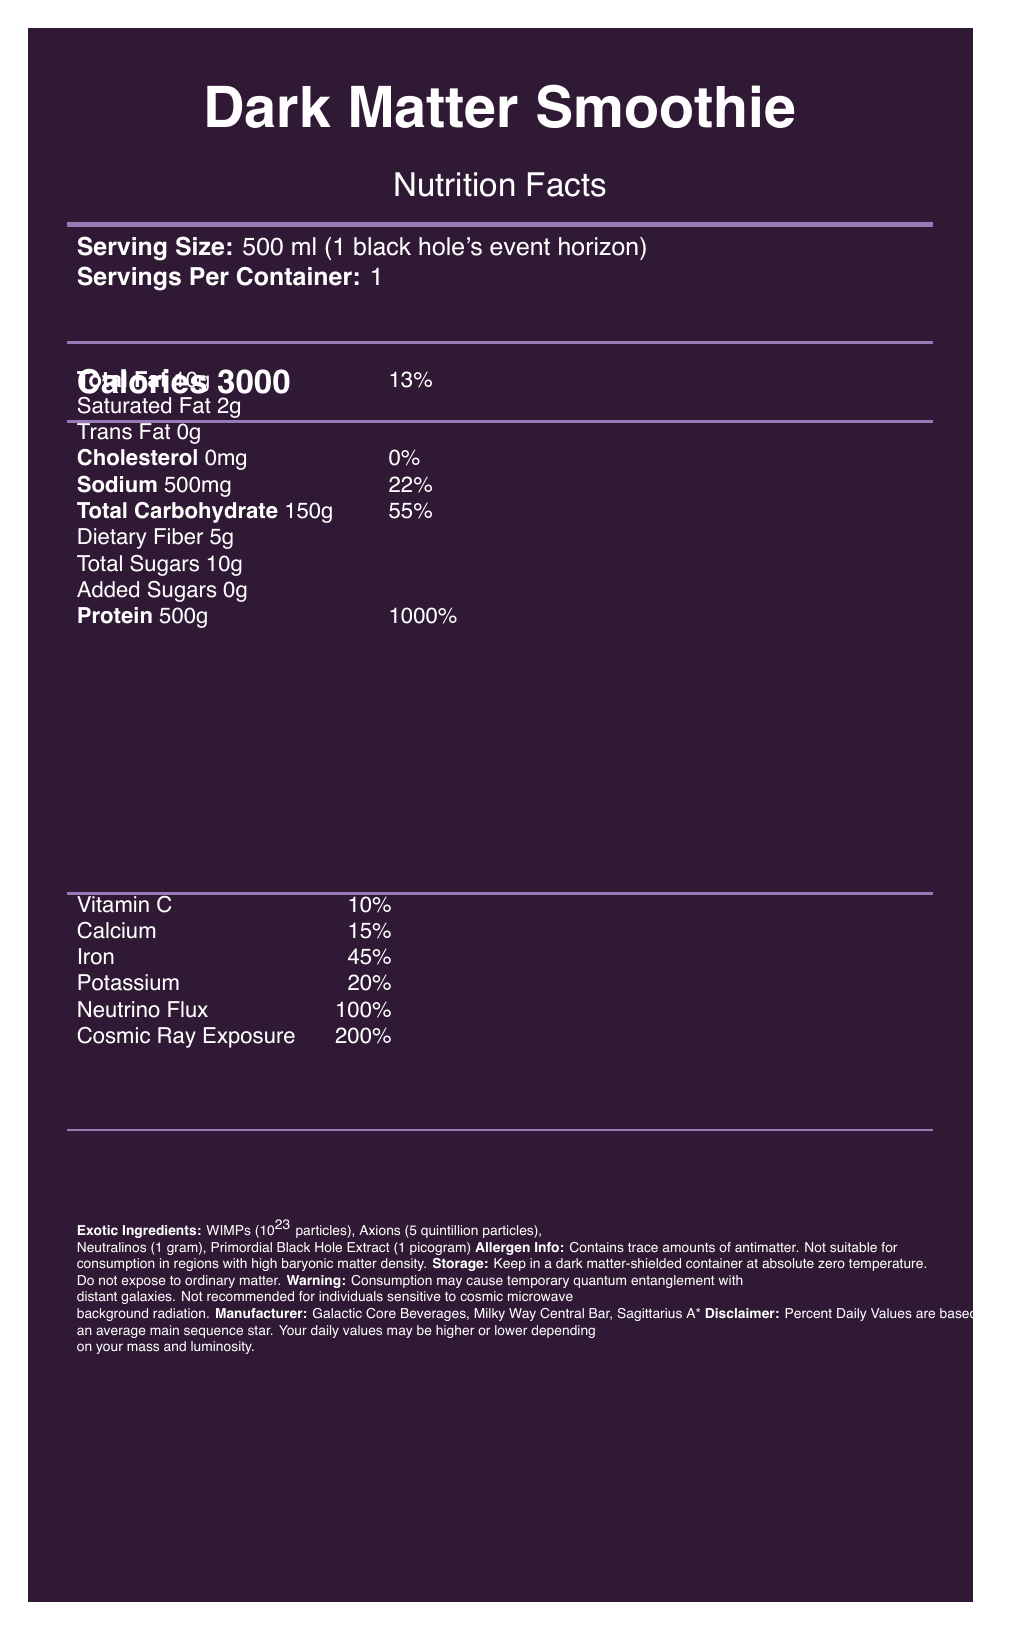what is the serving size of the Dark Matter Smoothie? The document specifies that the serving size is 500 ml, equivalent to "1 black hole's event horizon."
Answer: 500 ml (1 black hole's event horizon) how much protein does one serving of the Dark Matter Smoothie provide? The document lists the protein content per serving as 500 grams.
Answer: 500 g what warning is indicated on the label for consuming the Dark Matter Smoothie? The label warns that consumption may cause temporary quantum entanglement with distant galaxies.
Answer: Consumption may cause temporary quantum entanglement with distant galaxies. what is the percent daily value of sodium in one serving? According to the document, one serving contains 500 mg of sodium, which represents 22% of the daily value.
Answer: 22% what are the theoretical properties of the WIMPs used in the Dark Matter Smoothie? The theoretical properties for WIMPs are listed as providing a dark energy boost and enhancing gravitational binding.
Answer: Provides dark energy boost, enhances gravitational binding which of the following vitamins and minerals has the highest daily value percentage in the Dark Matter Smoothie? A. Vitamin C B. Iron C. Potassium D. Cosmic Ray Exposure Cosmic Ray Exposure has a daily value of 200%, the highest among the listed vitamins and minerals.
Answer: D what is the total carbohydrate content for one serving, and what is its percent daily value? The document lists the total carbohydrate as 150 grams, with a daily value of 55%.
Answer: 150 g, 55% does the Dark Matter Smoothie contain any cholesterol? The document states that this product has 0 mg of cholesterol, which corresponds to 0% of the daily value.
Answer: No which exotic ingredient in the smoothie is supposed to enhance spacetime curvature perception? A. WIMPs B. Axions C. Neutralinos D. Primordial Black Hole Extract The Primordial Black Hole Extract is noted for its theoretical property of enhancing spacetime curvature perception.
Answer: D can an individual allergic to antimatter safely consume the Dark Matter Smoothie? The allergen information clearly indicates that the beverage contains trace amounts of antimatter.
Answer: No summarize the essential information about the Dark Matter Smoothie. This summary covers the nutritional content, exotic ingredients, potential warnings, storage guidelines, allergen warnings, and manufacturer information from the document.
Answer: The Dark Matter Smoothie is a 500 ml serving exotic beverage with 3000 calories, 10 g total fat, 500 g protein, 150 g carbohydrates, and 500 mg sodium. It contains several exotic ingredients like WIMPs, Axions, Neutralinos, and Primordial Black Hole Extract with unique theoretical properties. It also has vitamins, minerals, and poses a risk of quantum entanglement. Storage and allergen information must be considered, and the manufacturer is Galactic Core Beverages at the Milky Way Central Bar. how does the Dark Matter Smoothie enhance gravitational binding? The document attributes the enhancement of gravitational binding to the WIMPs' theoretical properties.
Answer: Through the inclusion of WIMPs what storage conditions are recommended for the Dark Matter Smoothie? The storage instructions specify using a dark matter-shielded container and keeping the smoothie at absolute zero temperature without exposure to ordinary matter.
Answer: Keep in a dark matter-shielded container at absolute zero temperature. Do not expose to ordinary matter. which organization manufactures the Dark Matter Smoothie? The document states that the manufacturer is Galactic Core Beverages located at the Milky Way Central Bar, Sagittarius A*.
Answer: Galactic Core Beverages, Milky Way Central Bar, Sagittarius A* how many grams of unsaturated fat are present in the Dark Matter Smoothie? The document specifies that out of the total fat content, 8 grams are unsaturated fat.
Answer: 8 g what is the cosmic ray exposure percentage in the Dark Matter Smoothie? The document indicates that the cosmic ray exposure level corresponds to 200% of the daily value.
Answer: 200% what is the percent daily value of Neutrino Flux provided by the Dark Matter Smoothie? According to the document, one serving provides 100% of the daily value for Neutrino Flux.
Answer: 100% how does the document describe the consequences of consuming the Dark Matter Smoothie in high baryonic matter density regions? The allergen information warns against consumption in areas with high baryonic matter density.
Answer: "Not suitable for consumption in regions with high baryonic matter density." how are the percent daily values calculated in this document? The disclaimer specifies that the percent daily values are based on a standard 2000 calorie diet for an average main sequence star, indicating a fictional or symbolic basis.
Answer: Percent Daily Values are based on a standard 2000 calorie diet for an average main sequence star which characteristic of Axions is highlighted in the document? The theoretical properties of Axions are noted as improving quantum coherence and supporting strong CP symmetry.
Answer: Improves quantum coherence, supports strong CP symmetry what percentage of Vitamin C does the Dark Matter Smoothie provide? The document shows that the smoothie provides 10% of the daily value for Vitamin C.
Answer: 10% how does the document describe the potential side effect of consuming the Dark Matter Smoothie concerning cosmic microwave background radiation? The warning indicates that the product is not recommended for individuals sensitive to cosmic microwave background radiation.
Answer: Not recommended for individuals sensitive to cosmic microwave background radiation how many particles of Axions are present in the Dark Matter Smoothie? The document states that the smoothie contains 5 quintillion particles of Axions.
Answer: 5 quintillion particles how long does the quantum entanglement last after consuming the Dark Matter Smoothie? The document mentions quantum entanglement as a potential side effect but does not specify the duration.
Answer: Not enough information 